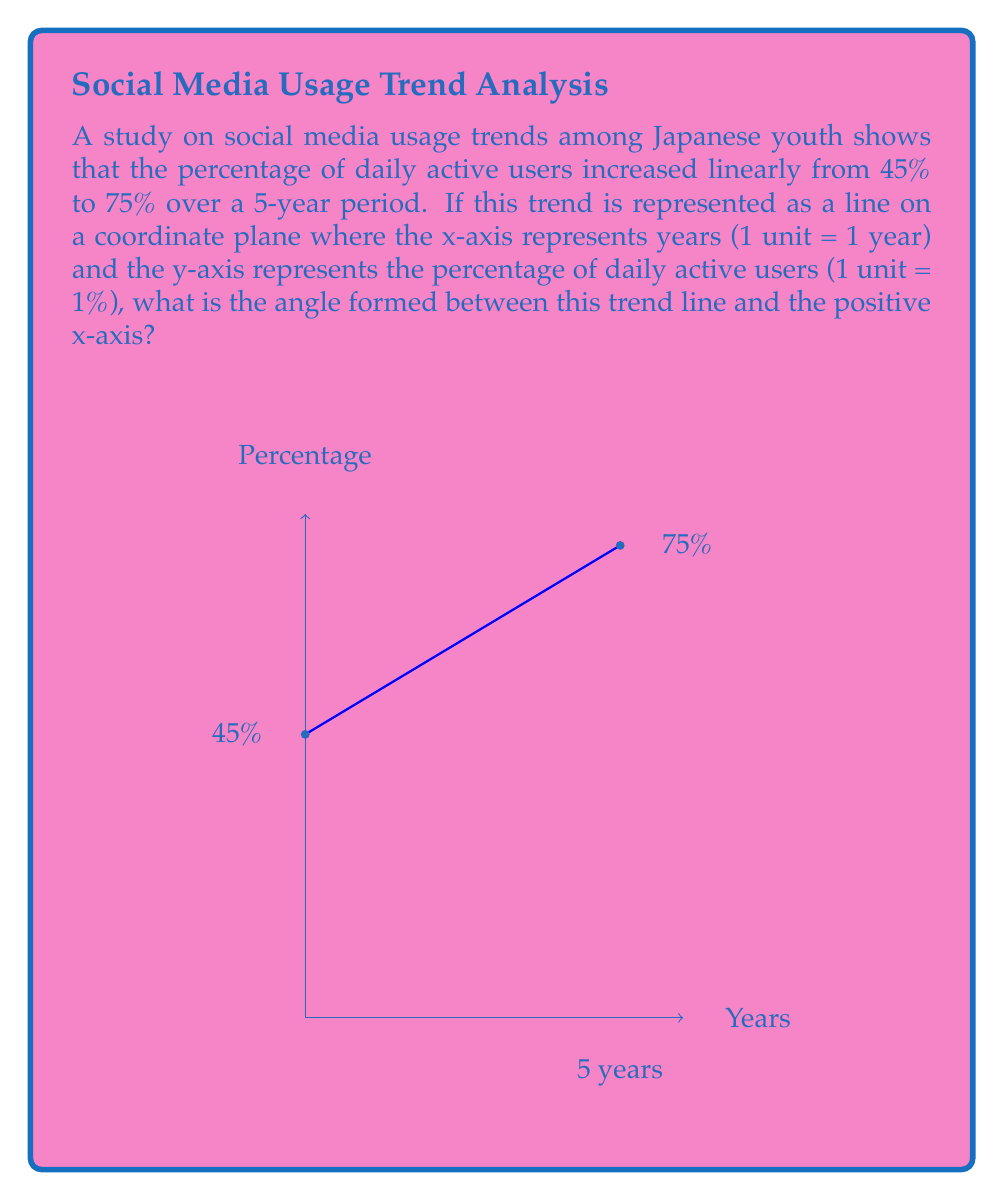Give your solution to this math problem. To solve this problem, we'll follow these steps:

1) First, we need to calculate the slope of the line. The slope represents the rate of change in the y-axis (percentage) with respect to the x-axis (years).

   Slope = $\frac{\text{change in y}}{\text{change in x}} = \frac{75\% - 45\%}{5 \text{ years}} = \frac{30\%}{5 \text{ years}} = 6\% \text{ per year}$

2) Now, we need to convert this slope to an angle. The angle we're looking for is the one formed between the line and the positive x-axis. This angle is the same as the arctangent of the slope.

3) However, we need to be careful about units. Our slope is 6% per year, but on our graph, 1 unit on the y-axis represents 1%, and 1 unit on the x-axis represents 1 year. So our slope in graph units is already 6.

4) We can now use the arctangent function to find the angle:

   $\theta = \arctan(6)$

5) Using a calculator or trigonometric tables, we find:

   $\theta \approx 80.54°$

Thus, the angle formed between the trend line and the positive x-axis is approximately 80.54°.
Answer: $80.54°$ 